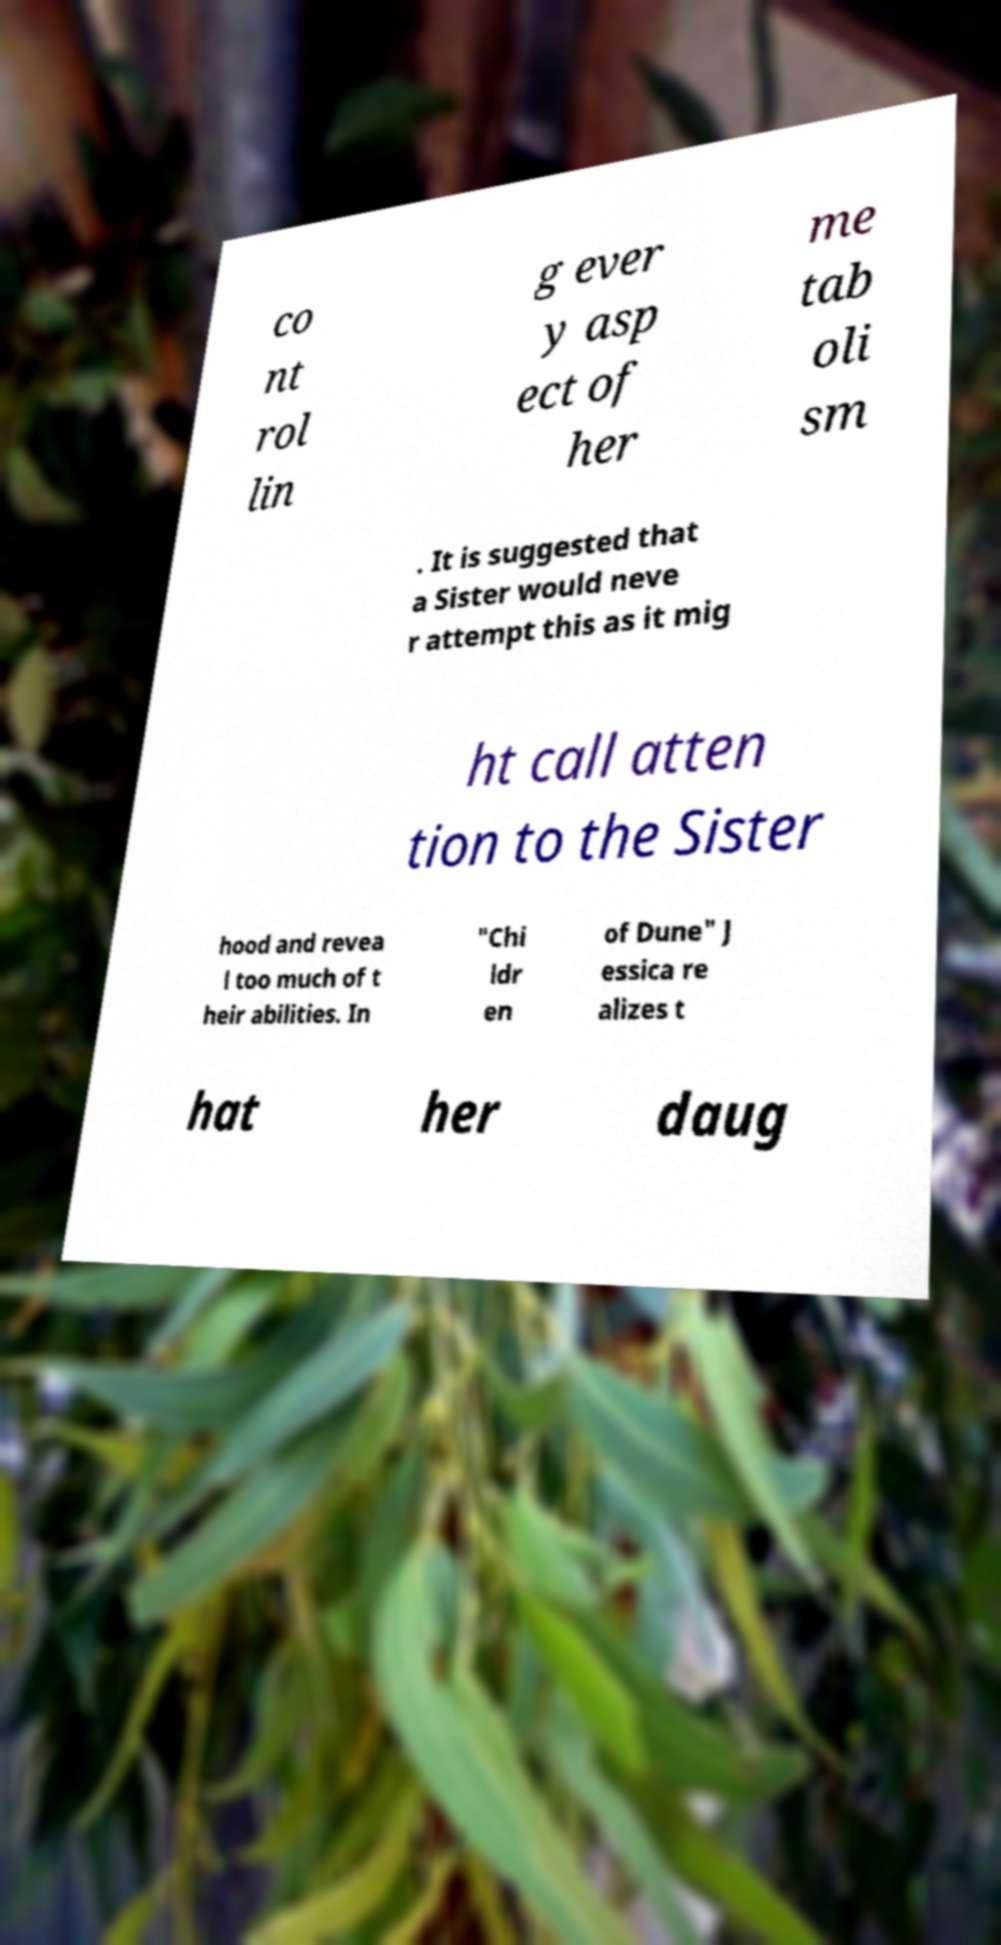There's text embedded in this image that I need extracted. Can you transcribe it verbatim? co nt rol lin g ever y asp ect of her me tab oli sm . It is suggested that a Sister would neve r attempt this as it mig ht call atten tion to the Sister hood and revea l too much of t heir abilities. In "Chi ldr en of Dune" J essica re alizes t hat her daug 